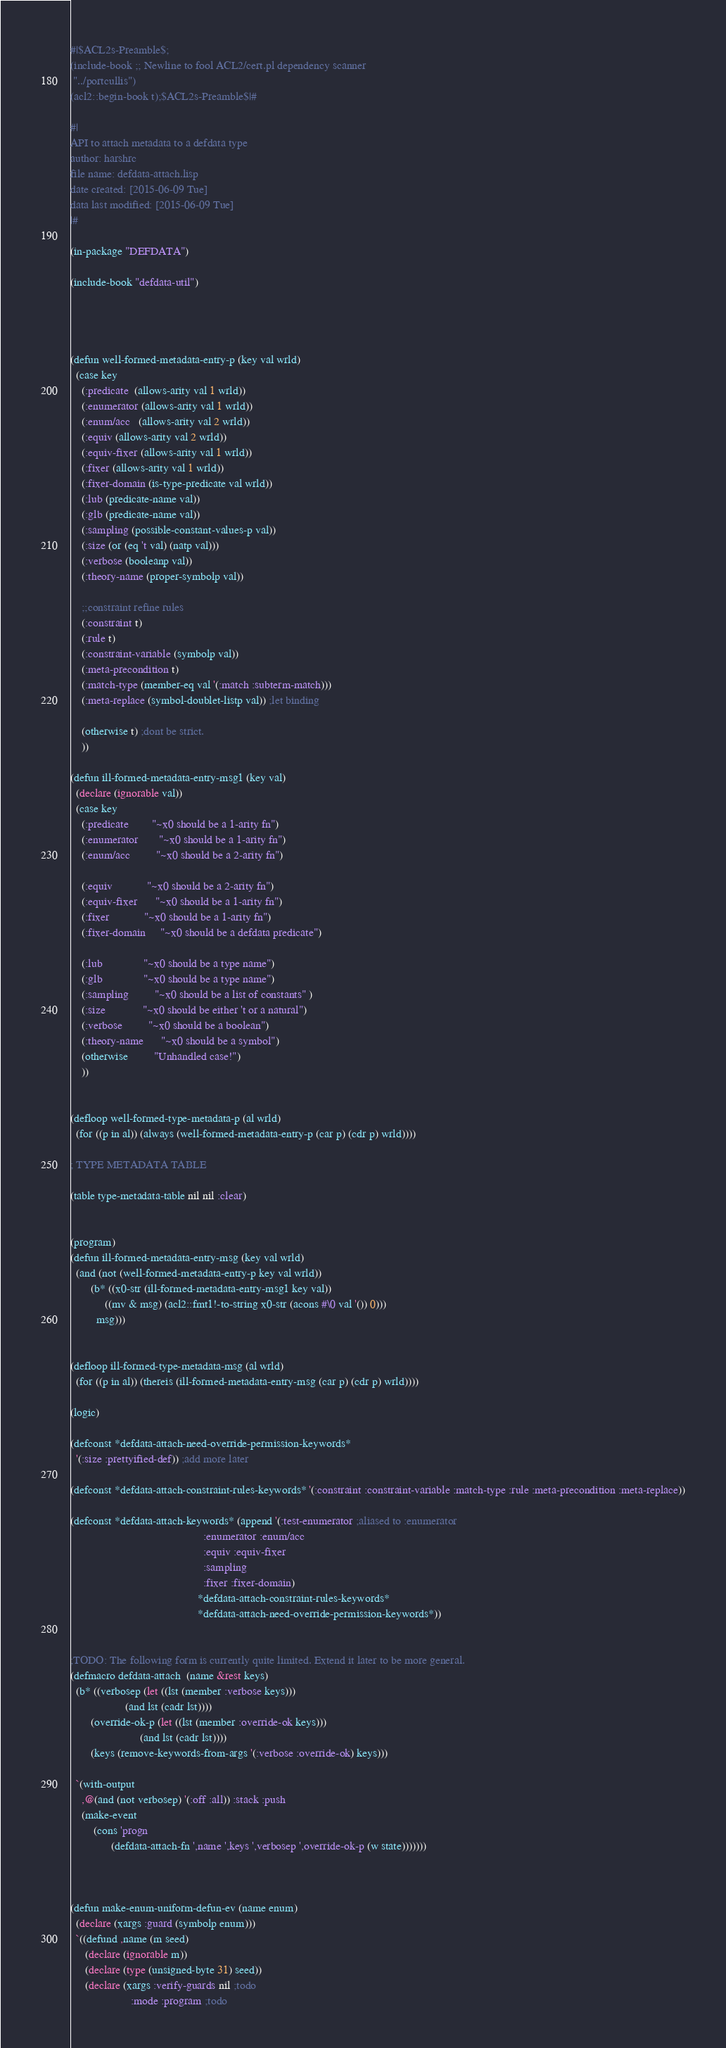<code> <loc_0><loc_0><loc_500><loc_500><_Lisp_>#|$ACL2s-Preamble$;
(include-book ;; Newline to fool ACL2/cert.pl dependency scanner
 "../portcullis")
(acl2::begin-book t);$ACL2s-Preamble$|#

#|
API to attach metadata to a defdata type
author: harshrc
file name: defdata-attach.lisp
date created: [2015-06-09 Tue]
data last modified: [2015-06-09 Tue]
|#

(in-package "DEFDATA")

(include-book "defdata-util")




(defun well-formed-metadata-entry-p (key val wrld)
  (case key
    (:predicate  (allows-arity val 1 wrld))
    (:enumerator (allows-arity val 1 wrld))
    (:enum/acc   (allows-arity val 2 wrld))
    (:equiv (allows-arity val 2 wrld))
    (:equiv-fixer (allows-arity val 1 wrld))
    (:fixer (allows-arity val 1 wrld))
    (:fixer-domain (is-type-predicate val wrld))
    (:lub (predicate-name val))
    (:glb (predicate-name val))
    (:sampling (possible-constant-values-p val))
    (:size (or (eq 't val) (natp val)))
    (:verbose (booleanp val))
    (:theory-name (proper-symbolp val))

    ;;constraint refine rules
    (:constraint t)
    (:rule t)
    (:constraint-variable (symbolp val))
    (:meta-precondition t)
    (:match-type (member-eq val '(:match :subterm-match)))
    (:meta-replace (symbol-doublet-listp val)) ;let binding

    (otherwise t) ;dont be strict.
    ))

(defun ill-formed-metadata-entry-msg1 (key val)
  (declare (ignorable val))
  (case key
    (:predicate        "~x0 should be a 1-arity fn")
    (:enumerator       "~x0 should be a 1-arity fn")
    (:enum/acc         "~x0 should be a 2-arity fn")

    (:equiv            "~x0 should be a 2-arity fn")
    (:equiv-fixer      "~x0 should be a 1-arity fn")
    (:fixer            "~x0 should be a 1-arity fn")
    (:fixer-domain     "~x0 should be a defdata predicate")

    (:lub              "~x0 should be a type name")
    (:glb              "~x0 should be a type name")
    (:sampling         "~x0 should be a list of constants" )
    (:size             "~x0 should be either 't or a natural")
    (:verbose         "~x0 should be a boolean")
    (:theory-name      "~x0 should be a symbol")
    (otherwise         "Unhandled case!")
    ))


(defloop well-formed-type-metadata-p (al wrld)
  (for ((p in al)) (always (well-formed-metadata-entry-p (car p) (cdr p) wrld))))

; TYPE METADATA TABLE

(table type-metadata-table nil nil :clear)


(program)
(defun ill-formed-metadata-entry-msg (key val wrld)
  (and (not (well-formed-metadata-entry-p key val wrld))
       (b* ((x0-str (ill-formed-metadata-entry-msg1 key val))
            ((mv & msg) (acl2::fmt1!-to-string x0-str (acons #\0 val '()) 0)))
         msg)))


(defloop ill-formed-type-metadata-msg (al wrld)
  (for ((p in al)) (thereis (ill-formed-metadata-entry-msg (car p) (cdr p) wrld))))

(logic)

(defconst *defdata-attach-need-override-permission-keywords*
  '(:size :prettyified-def)) ;add more later

(defconst *defdata-attach-constraint-rules-keywords* '(:constraint :constraint-variable :match-type :rule :meta-precondition :meta-replace))

(defconst *defdata-attach-keywords* (append '(:test-enumerator ;aliased to :enumerator
                                              :enumerator :enum/acc
                                              :equiv :equiv-fixer
                                              :sampling
                                              :fixer :fixer-domain)
                                            *defdata-attach-constraint-rules-keywords*
                                            *defdata-attach-need-override-permission-keywords*))


;TODO: The following form is currently quite limited. Extend it later to be more general.
(defmacro defdata-attach  (name &rest keys)
  (b* ((verbosep (let ((lst (member :verbose keys)))
                   (and lst (cadr lst))))
       (override-ok-p (let ((lst (member :override-ok keys)))
                        (and lst (cadr lst))))
       (keys (remove-keywords-from-args '(:verbose :override-ok) keys)))

  `(with-output
    ,@(and (not verbosep) '(:off :all)) :stack :push
    (make-event
        (cons 'progn
              (defdata-attach-fn ',name ',keys ',verbosep ',override-ok-p (w state)))))))



(defun make-enum-uniform-defun-ev (name enum)
  (declare (xargs :guard (symbolp enum)))
  `((defund ,name (m seed)
     (declare (ignorable m))
     (declare (type (unsigned-byte 31) seed))
     (declare (xargs :verify-guards nil ;todo
                     :mode :program ;todo</code> 